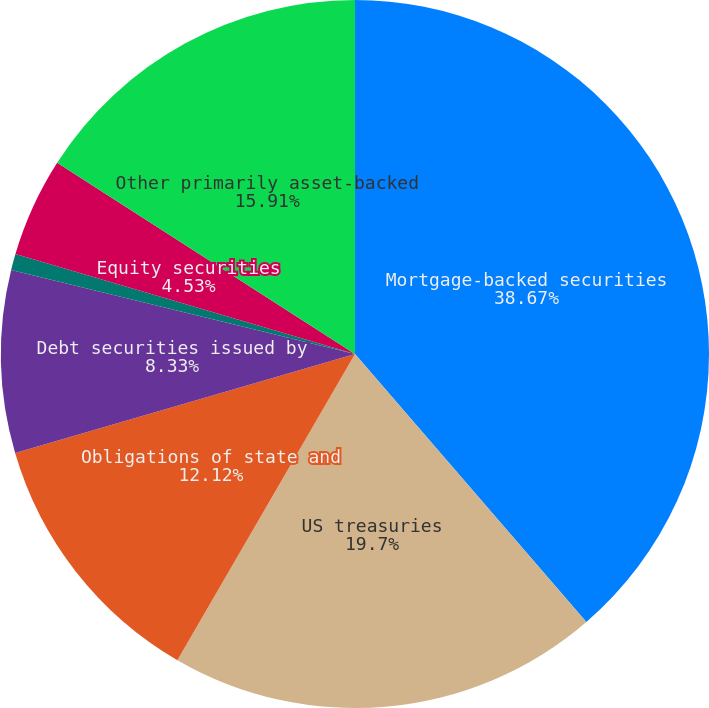Convert chart. <chart><loc_0><loc_0><loc_500><loc_500><pie_chart><fcel>Mortgage-backed securities<fcel>US treasuries<fcel>Obligations of state and<fcel>Debt securities issued by<fcel>Corporate debt securities<fcel>Equity securities<fcel>Other primarily asset-backed<nl><fcel>38.66%<fcel>19.7%<fcel>12.12%<fcel>8.33%<fcel>0.74%<fcel>4.53%<fcel>15.91%<nl></chart> 